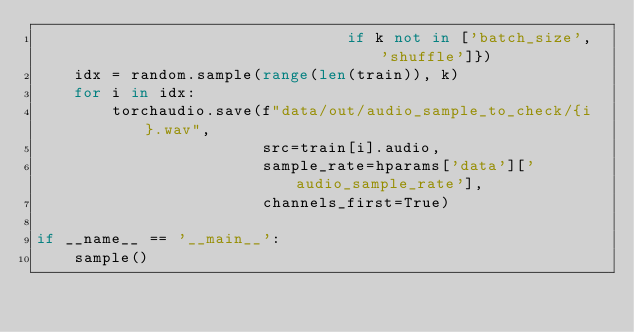Convert code to text. <code><loc_0><loc_0><loc_500><loc_500><_Python_>                                 if k not in ['batch_size', 'shuffle']})
    idx = random.sample(range(len(train)), k)
    for i in idx:
        torchaudio.save(f"data/out/audio_sample_to_check/{i}.wav",
                        src=train[i].audio,
                        sample_rate=hparams['data']['audio_sample_rate'],
                        channels_first=True)
        
if __name__ == '__main__':
    sample()
    
</code> 